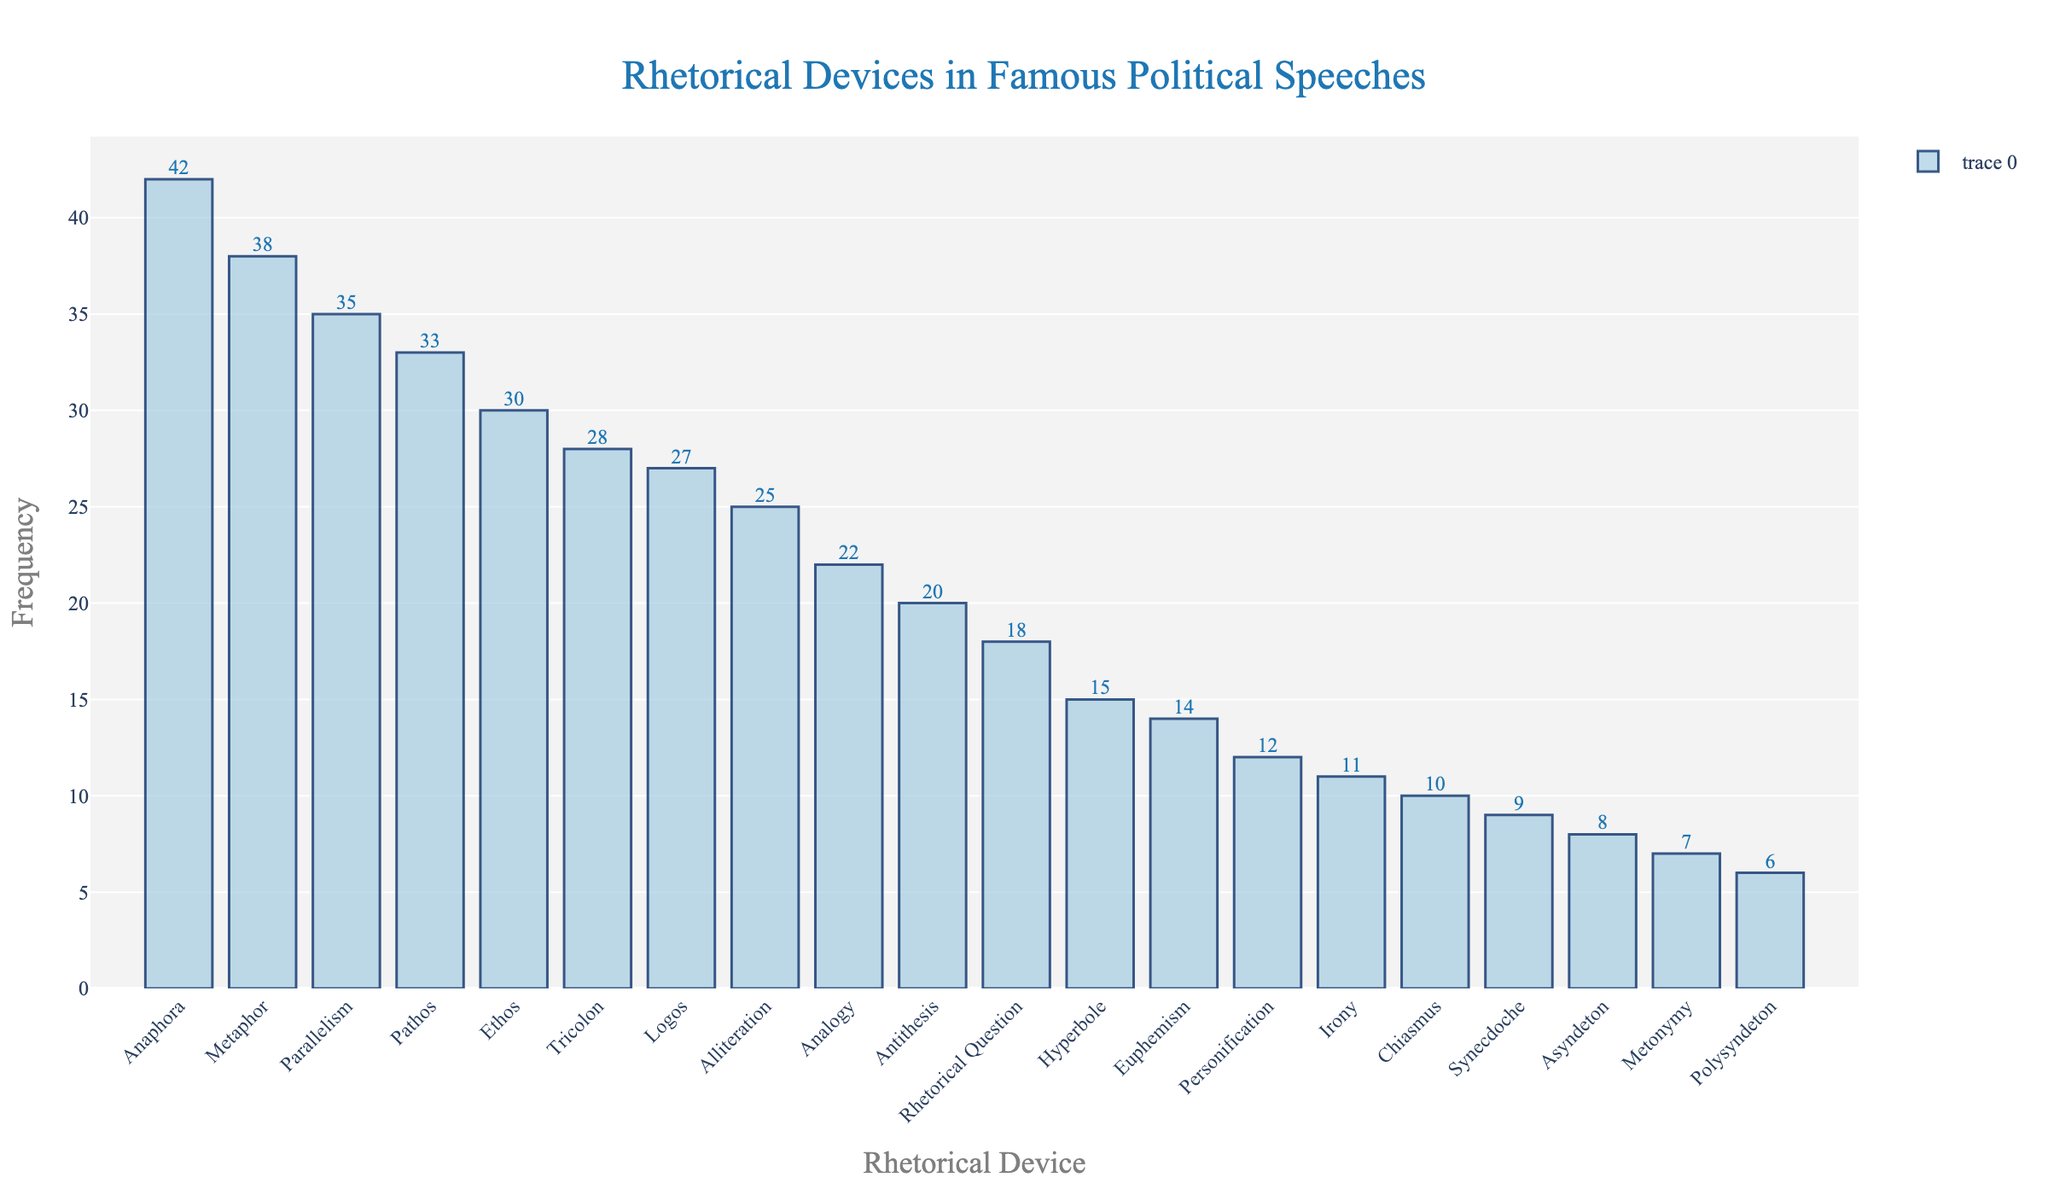Which rhetorical device is used most frequently in famous political speeches? The bar for 'Anaphora' is the highest among all the rhetorical devices shown in the plot, indicating that it has the highest frequency.
Answer: Anaphora What is the frequency difference between the most and least used rhetorical devices? The frequency of the most used device (Anaphora) is 42, and the least used device (Polysyndeton) is 6. The difference is 42 - 6 = 36.
Answer: 36 Among 'Metaphor', 'Parallelism', and 'Pathos', which device is used most frequently? 'Metaphor' has a frequency of 38, 'Parallelism' has 35, and 'Pathos' has 33. 'Metaphor' has the highest frequency among these three.
Answer: Metaphor How many rhetorical devices have been used more frequently than 'Ethos'? 'Ethos' has a frequency of 30. The devices with frequencies greater than 30 are 'Anaphora' (42), 'Metaphor' (38), 'Parallelism' (35), and 'Pathos' (33). There are 4 devices more frequently used than 'Ethos'.
Answer: 4 What's the combined frequency of 'Hyperbole', 'Euphemism', and 'Synecdoche'? The frequency of 'Hyperbole' is 15, 'Euphemism' is 14, and 'Synecdoche' is 9. Combined frequency is 15 + 14 + 9 = 38.
Answer: 38 Which is more frequently used, 'Irony' or 'Analogy'? The frequency of 'Irony' is 11, and the frequency of 'Analogy' is 22. 'Analogy' is used more frequently than 'Irony'.
Answer: Analogy Are 'Logos' and 'Alliteration' used with the same frequency? 'Logos' has a frequency of 27 and 'Alliteration' has 25, indicating they are not used with the same frequency.
Answer: No What is the median value of the frequencies of all listed rhetorical devices? To find the median, list the frequencies in ascending order and find the middle value. Frequencies in order are 6, 7, 8, 9, 10, 11, 12, 14, 15, 18, 20, 22, 25, 27, 28, 30, 33, 35, 38, 42. The median is the average of the 10th and 11th values: (18 + 20) / 2 = 19.
Answer: 19 Which is used more frequently, 'Chiasmus' or 'Asyndeton', and by how much? 'Chiasmus' has a frequency of 10 and 'Asyndeton' has 8. 'Chiasmus' is used more frequently by 10 - 8 = 2.
Answer: Chiasmus, by 2 